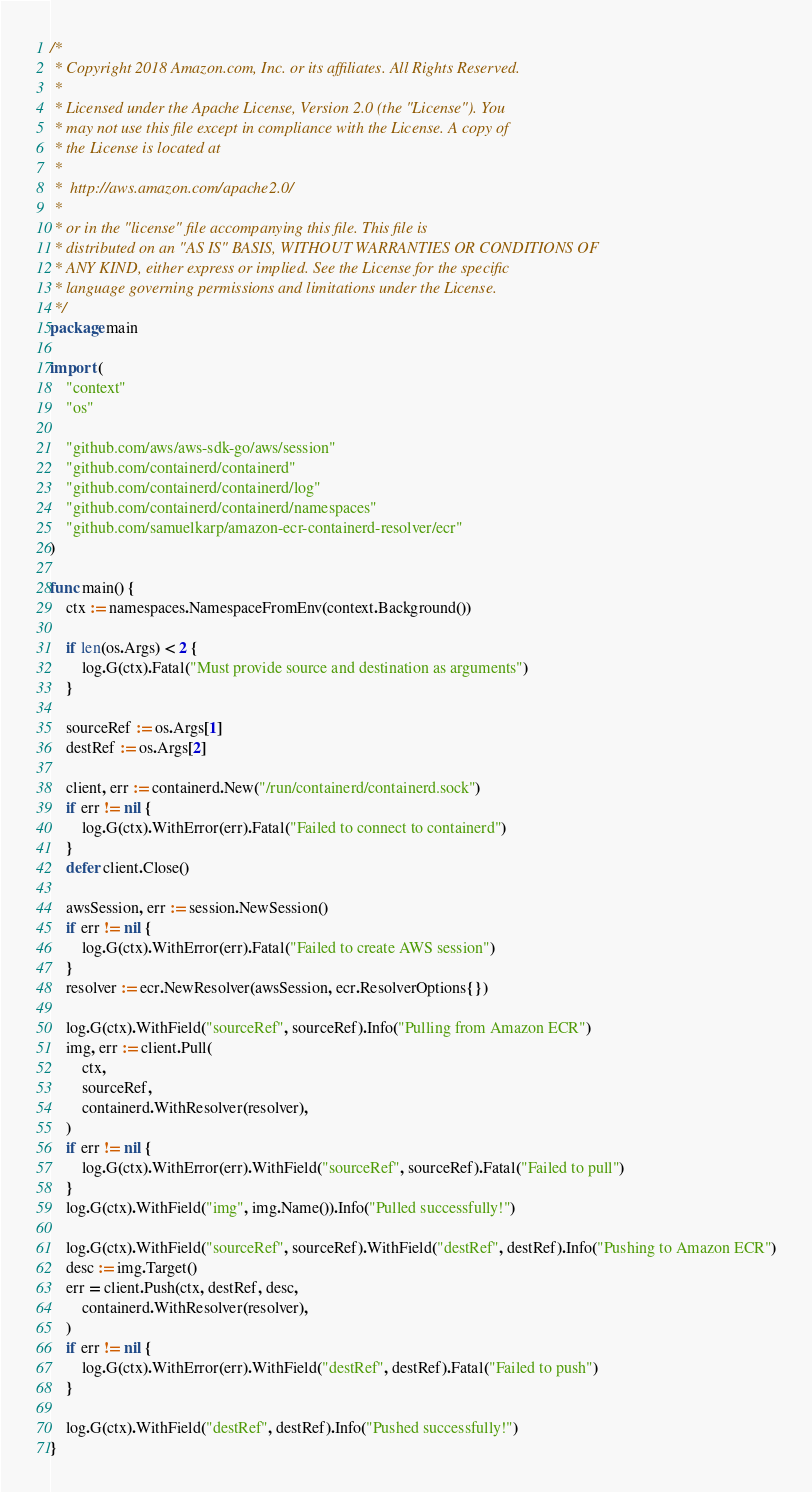Convert code to text. <code><loc_0><loc_0><loc_500><loc_500><_Go_>/*
 * Copyright 2018 Amazon.com, Inc. or its affiliates. All Rights Reserved.
 *
 * Licensed under the Apache License, Version 2.0 (the "License"). You
 * may not use this file except in compliance with the License. A copy of
 * the License is located at
 *
 * 	http://aws.amazon.com/apache2.0/
 *
 * or in the "license" file accompanying this file. This file is
 * distributed on an "AS IS" BASIS, WITHOUT WARRANTIES OR CONDITIONS OF
 * ANY KIND, either express or implied. See the License for the specific
 * language governing permissions and limitations under the License.
 */
package main

import (
	"context"
	"os"

	"github.com/aws/aws-sdk-go/aws/session"
	"github.com/containerd/containerd"
	"github.com/containerd/containerd/log"
	"github.com/containerd/containerd/namespaces"
	"github.com/samuelkarp/amazon-ecr-containerd-resolver/ecr"
)

func main() {
	ctx := namespaces.NamespaceFromEnv(context.Background())

	if len(os.Args) < 2 {
		log.G(ctx).Fatal("Must provide source and destination as arguments")
	}

	sourceRef := os.Args[1]
	destRef := os.Args[2]

	client, err := containerd.New("/run/containerd/containerd.sock")
	if err != nil {
		log.G(ctx).WithError(err).Fatal("Failed to connect to containerd")
	}
	defer client.Close()

	awsSession, err := session.NewSession()
	if err != nil {
		log.G(ctx).WithError(err).Fatal("Failed to create AWS session")
	}
	resolver := ecr.NewResolver(awsSession, ecr.ResolverOptions{})

	log.G(ctx).WithField("sourceRef", sourceRef).Info("Pulling from Amazon ECR")
	img, err := client.Pull(
		ctx,
		sourceRef,
		containerd.WithResolver(resolver),
	)
	if err != nil {
		log.G(ctx).WithError(err).WithField("sourceRef", sourceRef).Fatal("Failed to pull")
	}
	log.G(ctx).WithField("img", img.Name()).Info("Pulled successfully!")

	log.G(ctx).WithField("sourceRef", sourceRef).WithField("destRef", destRef).Info("Pushing to Amazon ECR")
	desc := img.Target()
	err = client.Push(ctx, destRef, desc,
		containerd.WithResolver(resolver),
	)
	if err != nil {
		log.G(ctx).WithError(err).WithField("destRef", destRef).Fatal("Failed to push")
	}

	log.G(ctx).WithField("destRef", destRef).Info("Pushed successfully!")
}
</code> 